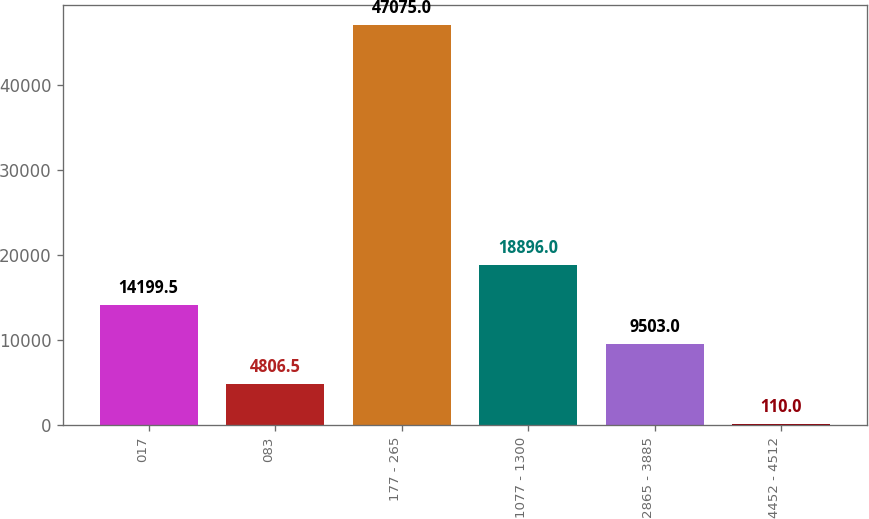<chart> <loc_0><loc_0><loc_500><loc_500><bar_chart><fcel>017<fcel>083<fcel>177 - 265<fcel>1077 - 1300<fcel>2865 - 3885<fcel>4452 - 4512<nl><fcel>14199.5<fcel>4806.5<fcel>47075<fcel>18896<fcel>9503<fcel>110<nl></chart> 